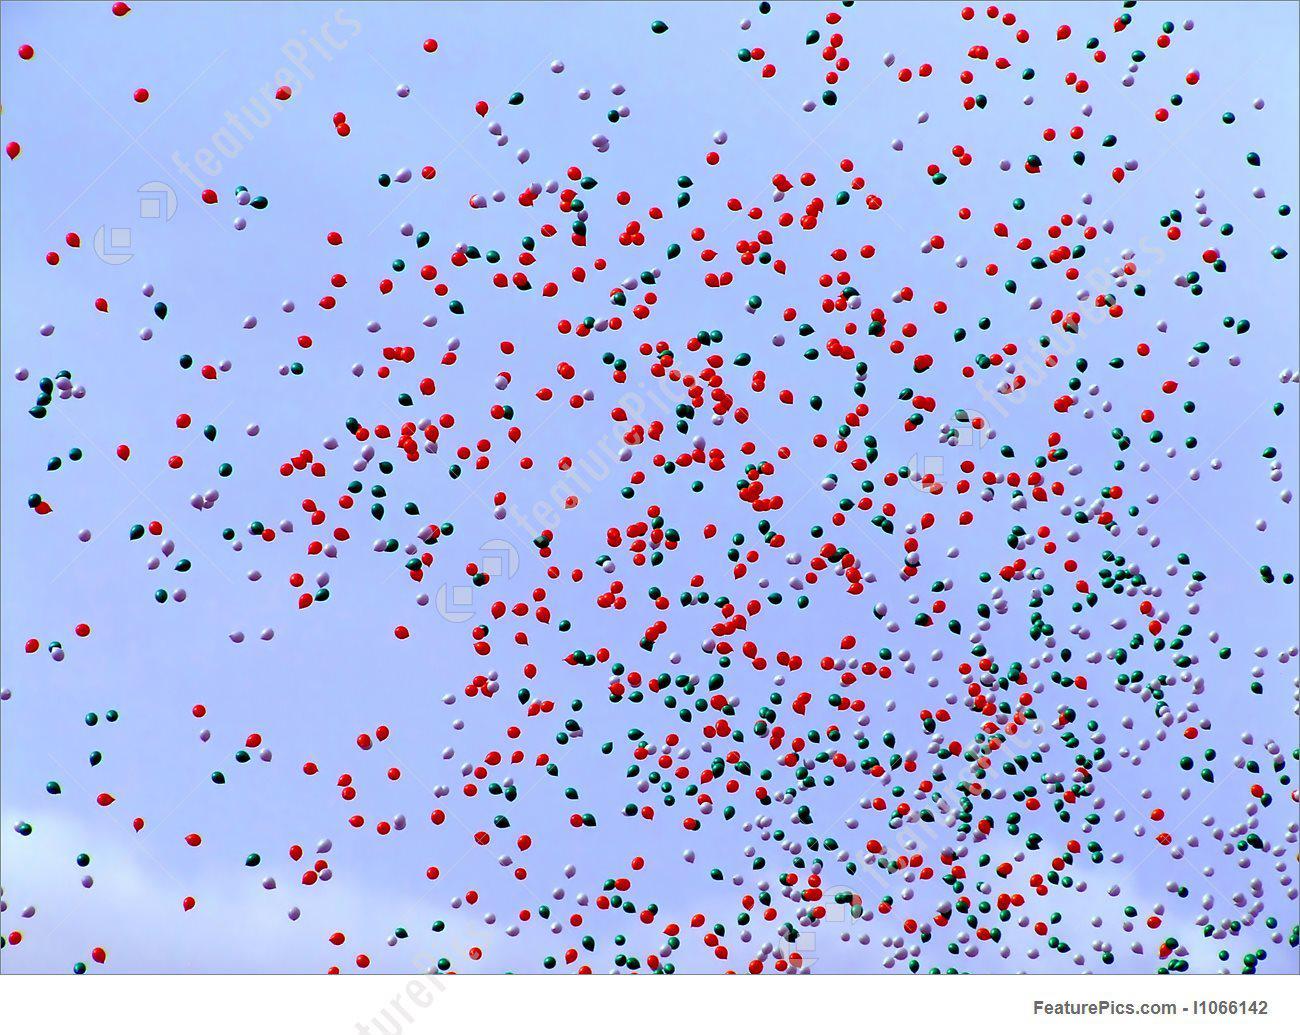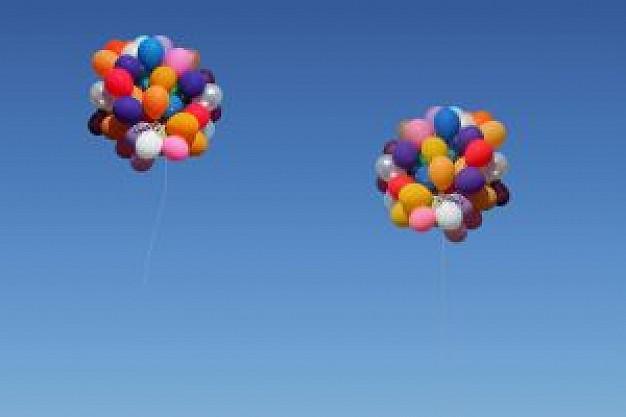The first image is the image on the left, the second image is the image on the right. For the images displayed, is the sentence "There are three hot air balloons." factually correct? Answer yes or no. No. The first image is the image on the left, the second image is the image on the right. For the images shown, is this caption "There are balloons tied together." true? Answer yes or no. Yes. 